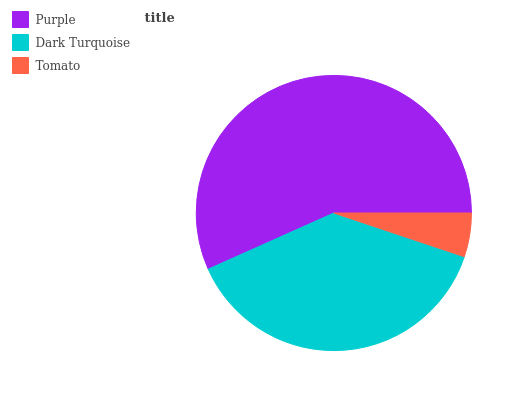Is Tomato the minimum?
Answer yes or no. Yes. Is Purple the maximum?
Answer yes or no. Yes. Is Dark Turquoise the minimum?
Answer yes or no. No. Is Dark Turquoise the maximum?
Answer yes or no. No. Is Purple greater than Dark Turquoise?
Answer yes or no. Yes. Is Dark Turquoise less than Purple?
Answer yes or no. Yes. Is Dark Turquoise greater than Purple?
Answer yes or no. No. Is Purple less than Dark Turquoise?
Answer yes or no. No. Is Dark Turquoise the high median?
Answer yes or no. Yes. Is Dark Turquoise the low median?
Answer yes or no. Yes. Is Purple the high median?
Answer yes or no. No. Is Purple the low median?
Answer yes or no. No. 